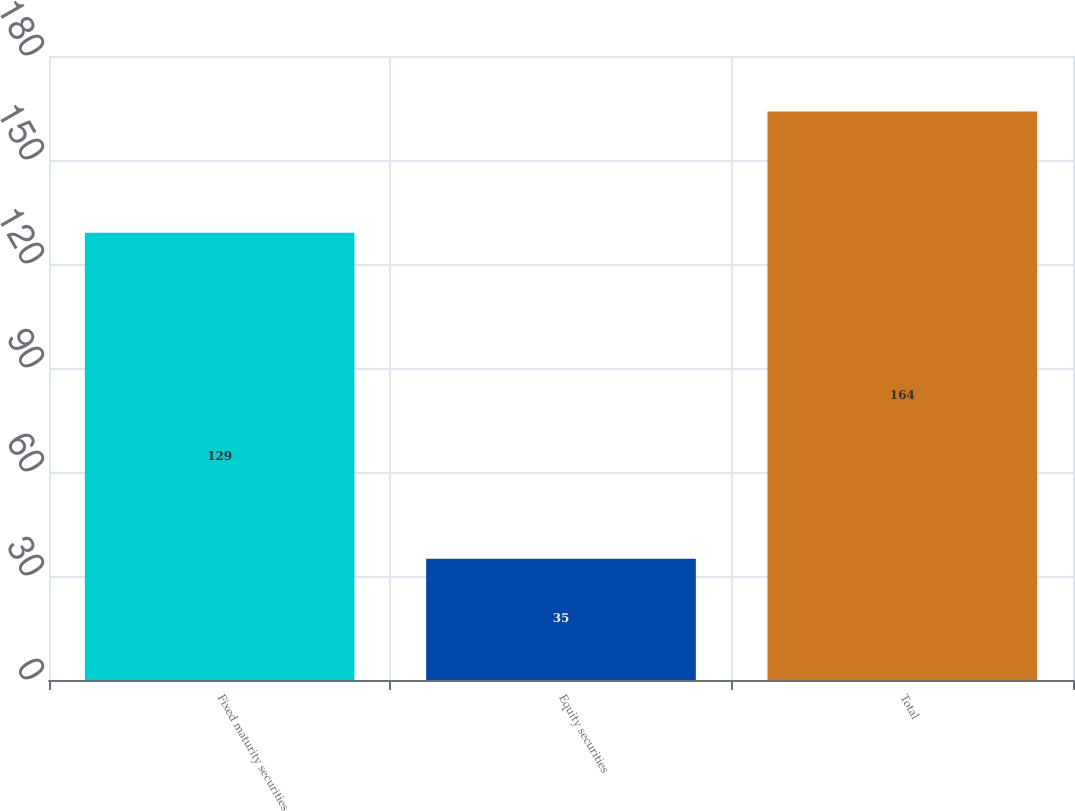<chart> <loc_0><loc_0><loc_500><loc_500><bar_chart><fcel>Fixed maturity securities<fcel>Equity securities<fcel>Total<nl><fcel>129<fcel>35<fcel>164<nl></chart> 